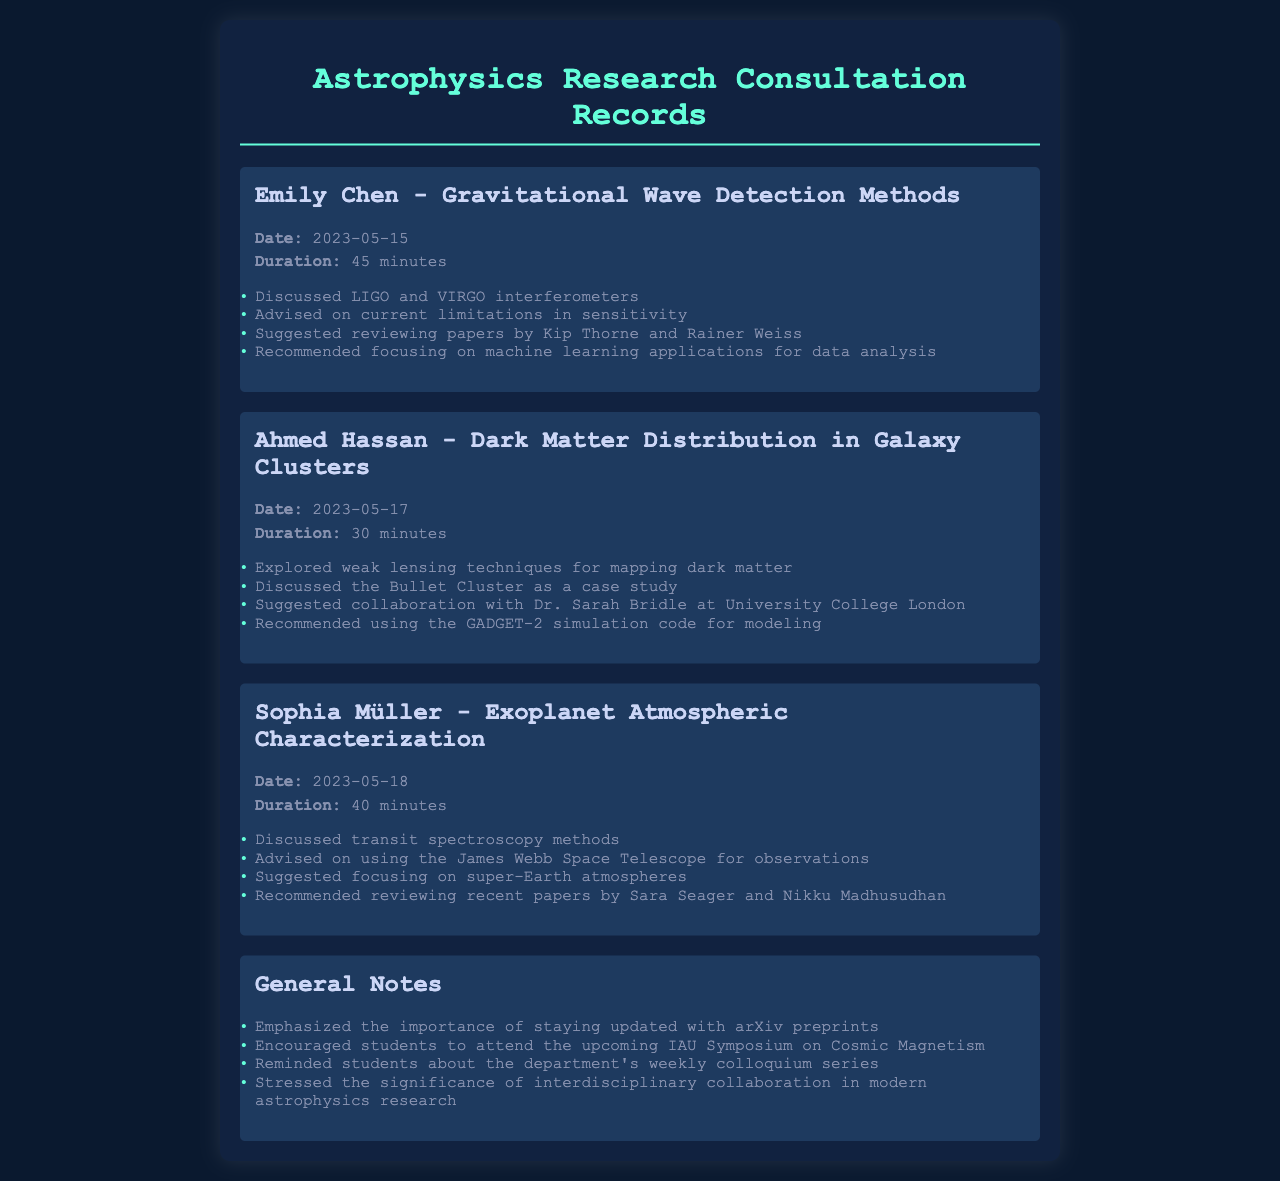What is the date of Emily Chen's consultation? The date is mentioned in Emily Chen's consultation section under the "Date:" heading.
Answer: 2023-05-15 How long did Ahmed Hassan's consultation last? The consultation duration is specified under the "Duration:" heading in Ahmed Hassan's section.
Answer: 30 minutes What research topic did Sophia Müller focus on? The research topic is indicated in the title of Sophia Müller's consultation section.
Answer: Exoplanet Atmospheric Characterization Who did Ahmed Hassan suggest collaborating with? The collaboration suggestion is found in Ahmed Hassan's consultation section under the relevant bullet point.
Answer: Dr. Sarah Bridle What is a recommended method for Emily Chen's project? The recommended method is listed under Emily Chen’s consultation details.
Answer: Machine learning applications for data analysis What general advice was given regarding arXiv preprints? The general advice is mentioned in the General Notes section of the document.
Answer: Staying updated How many consultations are listed in the document? The number of consultations can be counted from the consultation sections present.
Answer: Three What is the emphasized significance mentioned in the General Notes? The significance is articulated in last bullet point of the General Notes section.
Answer: Interdisciplinary collaboration What case study did Ahmed Hassan discuss? The case study is referenced in Ahmed Hassan's consultation section.
Answer: Bullet Cluster 